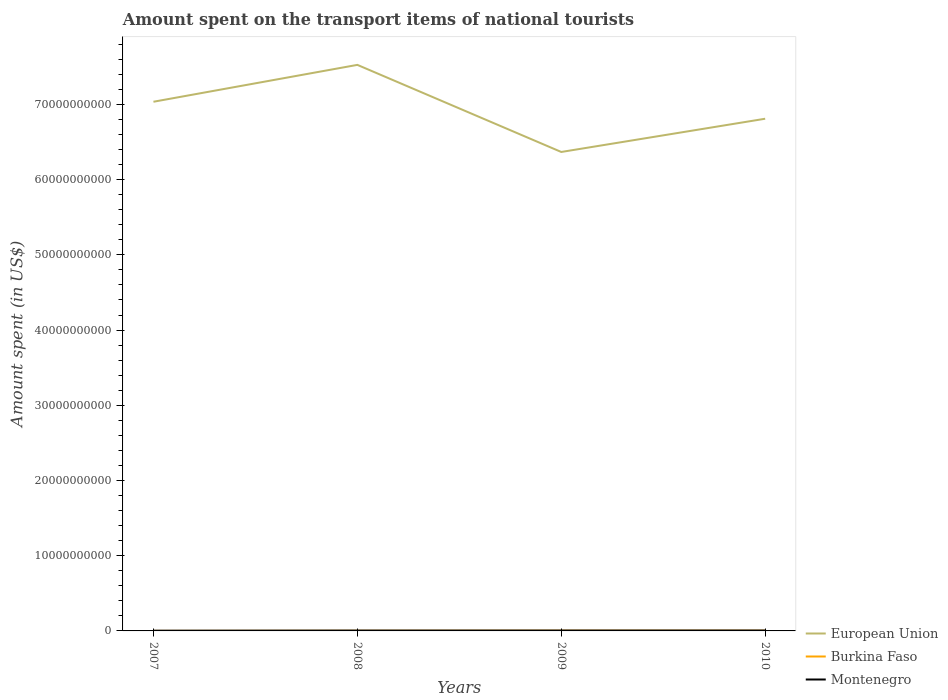How many different coloured lines are there?
Provide a succinct answer. 3. Across all years, what is the maximum amount spent on the transport items of national tourists in Montenegro?
Offer a terse response. 3.00e+07. What is the total amount spent on the transport items of national tourists in Montenegro in the graph?
Ensure brevity in your answer.  -2.20e+07. What is the difference between the highest and the second highest amount spent on the transport items of national tourists in Burkina Faso?
Offer a very short reply. 2.80e+07. What is the difference between the highest and the lowest amount spent on the transport items of national tourists in Montenegro?
Make the answer very short. 3. Is the amount spent on the transport items of national tourists in European Union strictly greater than the amount spent on the transport items of national tourists in Montenegro over the years?
Keep it short and to the point. No. How many lines are there?
Ensure brevity in your answer.  3. How many years are there in the graph?
Provide a succinct answer. 4. Are the values on the major ticks of Y-axis written in scientific E-notation?
Your answer should be compact. No. Does the graph contain grids?
Provide a short and direct response. No. What is the title of the graph?
Your answer should be compact. Amount spent on the transport items of national tourists. Does "Palau" appear as one of the legend labels in the graph?
Keep it short and to the point. No. What is the label or title of the Y-axis?
Give a very brief answer. Amount spent (in US$). What is the Amount spent (in US$) in European Union in 2007?
Make the answer very short. 7.04e+1. What is the Amount spent (in US$) in Burkina Faso in 2007?
Your response must be concise. 5.00e+06. What is the Amount spent (in US$) of Montenegro in 2007?
Keep it short and to the point. 3.00e+07. What is the Amount spent (in US$) of European Union in 2008?
Your answer should be compact. 7.53e+1. What is the Amount spent (in US$) in Montenegro in 2008?
Offer a terse response. 4.60e+07. What is the Amount spent (in US$) of European Union in 2009?
Give a very brief answer. 6.37e+1. What is the Amount spent (in US$) in Burkina Faso in 2009?
Offer a terse response. 3.30e+07. What is the Amount spent (in US$) of Montenegro in 2009?
Your response must be concise. 4.70e+07. What is the Amount spent (in US$) in European Union in 2010?
Give a very brief answer. 6.81e+1. What is the Amount spent (in US$) in Burkina Faso in 2010?
Keep it short and to the point. 3.30e+07. What is the Amount spent (in US$) in Montenegro in 2010?
Your response must be concise. 5.20e+07. Across all years, what is the maximum Amount spent (in US$) in European Union?
Ensure brevity in your answer.  7.53e+1. Across all years, what is the maximum Amount spent (in US$) of Burkina Faso?
Keep it short and to the point. 3.30e+07. Across all years, what is the maximum Amount spent (in US$) of Montenegro?
Your answer should be very brief. 5.20e+07. Across all years, what is the minimum Amount spent (in US$) in European Union?
Keep it short and to the point. 6.37e+1. Across all years, what is the minimum Amount spent (in US$) in Montenegro?
Your answer should be very brief. 3.00e+07. What is the total Amount spent (in US$) in European Union in the graph?
Keep it short and to the point. 2.77e+11. What is the total Amount spent (in US$) in Burkina Faso in the graph?
Give a very brief answer. 9.10e+07. What is the total Amount spent (in US$) of Montenegro in the graph?
Provide a short and direct response. 1.75e+08. What is the difference between the Amount spent (in US$) of European Union in 2007 and that in 2008?
Keep it short and to the point. -4.90e+09. What is the difference between the Amount spent (in US$) in Burkina Faso in 2007 and that in 2008?
Offer a very short reply. -1.50e+07. What is the difference between the Amount spent (in US$) of Montenegro in 2007 and that in 2008?
Your answer should be compact. -1.60e+07. What is the difference between the Amount spent (in US$) of European Union in 2007 and that in 2009?
Provide a short and direct response. 6.68e+09. What is the difference between the Amount spent (in US$) in Burkina Faso in 2007 and that in 2009?
Your answer should be very brief. -2.80e+07. What is the difference between the Amount spent (in US$) of Montenegro in 2007 and that in 2009?
Provide a short and direct response. -1.70e+07. What is the difference between the Amount spent (in US$) of European Union in 2007 and that in 2010?
Ensure brevity in your answer.  2.26e+09. What is the difference between the Amount spent (in US$) of Burkina Faso in 2007 and that in 2010?
Keep it short and to the point. -2.80e+07. What is the difference between the Amount spent (in US$) in Montenegro in 2007 and that in 2010?
Make the answer very short. -2.20e+07. What is the difference between the Amount spent (in US$) in European Union in 2008 and that in 2009?
Your answer should be very brief. 1.16e+1. What is the difference between the Amount spent (in US$) of Burkina Faso in 2008 and that in 2009?
Make the answer very short. -1.30e+07. What is the difference between the Amount spent (in US$) of Montenegro in 2008 and that in 2009?
Provide a succinct answer. -1.00e+06. What is the difference between the Amount spent (in US$) in European Union in 2008 and that in 2010?
Your answer should be compact. 7.16e+09. What is the difference between the Amount spent (in US$) of Burkina Faso in 2008 and that in 2010?
Your answer should be compact. -1.30e+07. What is the difference between the Amount spent (in US$) of Montenegro in 2008 and that in 2010?
Ensure brevity in your answer.  -6.00e+06. What is the difference between the Amount spent (in US$) of European Union in 2009 and that in 2010?
Offer a very short reply. -4.42e+09. What is the difference between the Amount spent (in US$) in Burkina Faso in 2009 and that in 2010?
Your answer should be compact. 0. What is the difference between the Amount spent (in US$) of Montenegro in 2009 and that in 2010?
Your answer should be compact. -5.00e+06. What is the difference between the Amount spent (in US$) of European Union in 2007 and the Amount spent (in US$) of Burkina Faso in 2008?
Make the answer very short. 7.03e+1. What is the difference between the Amount spent (in US$) in European Union in 2007 and the Amount spent (in US$) in Montenegro in 2008?
Make the answer very short. 7.03e+1. What is the difference between the Amount spent (in US$) of Burkina Faso in 2007 and the Amount spent (in US$) of Montenegro in 2008?
Your answer should be compact. -4.10e+07. What is the difference between the Amount spent (in US$) of European Union in 2007 and the Amount spent (in US$) of Burkina Faso in 2009?
Provide a short and direct response. 7.03e+1. What is the difference between the Amount spent (in US$) of European Union in 2007 and the Amount spent (in US$) of Montenegro in 2009?
Your response must be concise. 7.03e+1. What is the difference between the Amount spent (in US$) of Burkina Faso in 2007 and the Amount spent (in US$) of Montenegro in 2009?
Your answer should be very brief. -4.20e+07. What is the difference between the Amount spent (in US$) in European Union in 2007 and the Amount spent (in US$) in Burkina Faso in 2010?
Provide a succinct answer. 7.03e+1. What is the difference between the Amount spent (in US$) in European Union in 2007 and the Amount spent (in US$) in Montenegro in 2010?
Provide a short and direct response. 7.03e+1. What is the difference between the Amount spent (in US$) in Burkina Faso in 2007 and the Amount spent (in US$) in Montenegro in 2010?
Your answer should be very brief. -4.70e+07. What is the difference between the Amount spent (in US$) of European Union in 2008 and the Amount spent (in US$) of Burkina Faso in 2009?
Offer a terse response. 7.52e+1. What is the difference between the Amount spent (in US$) of European Union in 2008 and the Amount spent (in US$) of Montenegro in 2009?
Your answer should be compact. 7.52e+1. What is the difference between the Amount spent (in US$) in Burkina Faso in 2008 and the Amount spent (in US$) in Montenegro in 2009?
Your response must be concise. -2.70e+07. What is the difference between the Amount spent (in US$) of European Union in 2008 and the Amount spent (in US$) of Burkina Faso in 2010?
Your response must be concise. 7.52e+1. What is the difference between the Amount spent (in US$) of European Union in 2008 and the Amount spent (in US$) of Montenegro in 2010?
Keep it short and to the point. 7.52e+1. What is the difference between the Amount spent (in US$) of Burkina Faso in 2008 and the Amount spent (in US$) of Montenegro in 2010?
Your answer should be compact. -3.20e+07. What is the difference between the Amount spent (in US$) of European Union in 2009 and the Amount spent (in US$) of Burkina Faso in 2010?
Keep it short and to the point. 6.36e+1. What is the difference between the Amount spent (in US$) of European Union in 2009 and the Amount spent (in US$) of Montenegro in 2010?
Your response must be concise. 6.36e+1. What is the difference between the Amount spent (in US$) in Burkina Faso in 2009 and the Amount spent (in US$) in Montenegro in 2010?
Keep it short and to the point. -1.90e+07. What is the average Amount spent (in US$) in European Union per year?
Offer a very short reply. 6.93e+1. What is the average Amount spent (in US$) in Burkina Faso per year?
Give a very brief answer. 2.28e+07. What is the average Amount spent (in US$) of Montenegro per year?
Offer a terse response. 4.38e+07. In the year 2007, what is the difference between the Amount spent (in US$) of European Union and Amount spent (in US$) of Burkina Faso?
Provide a short and direct response. 7.03e+1. In the year 2007, what is the difference between the Amount spent (in US$) of European Union and Amount spent (in US$) of Montenegro?
Your answer should be very brief. 7.03e+1. In the year 2007, what is the difference between the Amount spent (in US$) in Burkina Faso and Amount spent (in US$) in Montenegro?
Keep it short and to the point. -2.50e+07. In the year 2008, what is the difference between the Amount spent (in US$) of European Union and Amount spent (in US$) of Burkina Faso?
Give a very brief answer. 7.52e+1. In the year 2008, what is the difference between the Amount spent (in US$) of European Union and Amount spent (in US$) of Montenegro?
Your response must be concise. 7.52e+1. In the year 2008, what is the difference between the Amount spent (in US$) of Burkina Faso and Amount spent (in US$) of Montenegro?
Provide a succinct answer. -2.60e+07. In the year 2009, what is the difference between the Amount spent (in US$) in European Union and Amount spent (in US$) in Burkina Faso?
Your answer should be very brief. 6.36e+1. In the year 2009, what is the difference between the Amount spent (in US$) in European Union and Amount spent (in US$) in Montenegro?
Your response must be concise. 6.36e+1. In the year 2009, what is the difference between the Amount spent (in US$) of Burkina Faso and Amount spent (in US$) of Montenegro?
Your answer should be compact. -1.40e+07. In the year 2010, what is the difference between the Amount spent (in US$) of European Union and Amount spent (in US$) of Burkina Faso?
Offer a terse response. 6.81e+1. In the year 2010, what is the difference between the Amount spent (in US$) in European Union and Amount spent (in US$) in Montenegro?
Offer a very short reply. 6.80e+1. In the year 2010, what is the difference between the Amount spent (in US$) in Burkina Faso and Amount spent (in US$) in Montenegro?
Offer a very short reply. -1.90e+07. What is the ratio of the Amount spent (in US$) of European Union in 2007 to that in 2008?
Provide a succinct answer. 0.93. What is the ratio of the Amount spent (in US$) of Montenegro in 2007 to that in 2008?
Provide a short and direct response. 0.65. What is the ratio of the Amount spent (in US$) in European Union in 2007 to that in 2009?
Your answer should be very brief. 1.1. What is the ratio of the Amount spent (in US$) of Burkina Faso in 2007 to that in 2009?
Provide a succinct answer. 0.15. What is the ratio of the Amount spent (in US$) of Montenegro in 2007 to that in 2009?
Provide a short and direct response. 0.64. What is the ratio of the Amount spent (in US$) in European Union in 2007 to that in 2010?
Provide a short and direct response. 1.03. What is the ratio of the Amount spent (in US$) in Burkina Faso in 2007 to that in 2010?
Provide a short and direct response. 0.15. What is the ratio of the Amount spent (in US$) of Montenegro in 2007 to that in 2010?
Your answer should be very brief. 0.58. What is the ratio of the Amount spent (in US$) of European Union in 2008 to that in 2009?
Your response must be concise. 1.18. What is the ratio of the Amount spent (in US$) of Burkina Faso in 2008 to that in 2009?
Offer a terse response. 0.61. What is the ratio of the Amount spent (in US$) of Montenegro in 2008 to that in 2009?
Offer a very short reply. 0.98. What is the ratio of the Amount spent (in US$) in European Union in 2008 to that in 2010?
Ensure brevity in your answer.  1.11. What is the ratio of the Amount spent (in US$) in Burkina Faso in 2008 to that in 2010?
Provide a succinct answer. 0.61. What is the ratio of the Amount spent (in US$) in Montenegro in 2008 to that in 2010?
Keep it short and to the point. 0.88. What is the ratio of the Amount spent (in US$) in European Union in 2009 to that in 2010?
Keep it short and to the point. 0.94. What is the ratio of the Amount spent (in US$) in Montenegro in 2009 to that in 2010?
Make the answer very short. 0.9. What is the difference between the highest and the second highest Amount spent (in US$) of European Union?
Offer a very short reply. 4.90e+09. What is the difference between the highest and the second highest Amount spent (in US$) of Burkina Faso?
Make the answer very short. 0. What is the difference between the highest and the second highest Amount spent (in US$) in Montenegro?
Provide a succinct answer. 5.00e+06. What is the difference between the highest and the lowest Amount spent (in US$) of European Union?
Offer a terse response. 1.16e+1. What is the difference between the highest and the lowest Amount spent (in US$) in Burkina Faso?
Your answer should be very brief. 2.80e+07. What is the difference between the highest and the lowest Amount spent (in US$) in Montenegro?
Your answer should be very brief. 2.20e+07. 